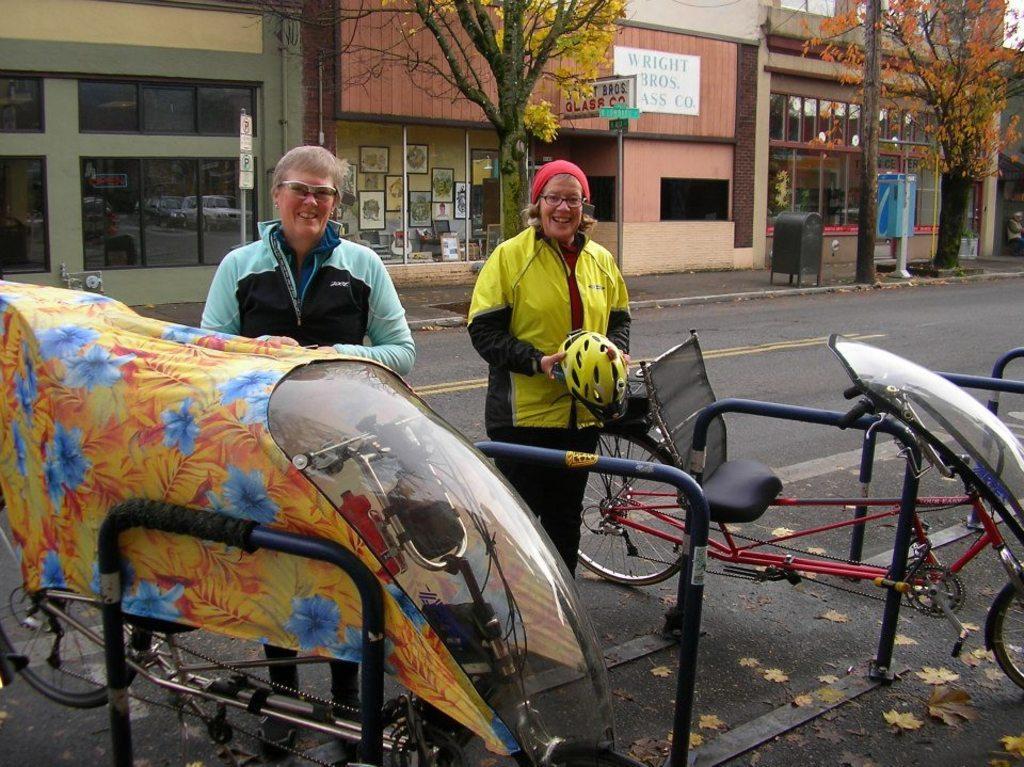Please provide a concise description of this image. In the center of the image we can see two people standing. The lady standing on the right is holding a helmet. At the bottom there are bicycles. In the background there are trees, buildings and a bin. 